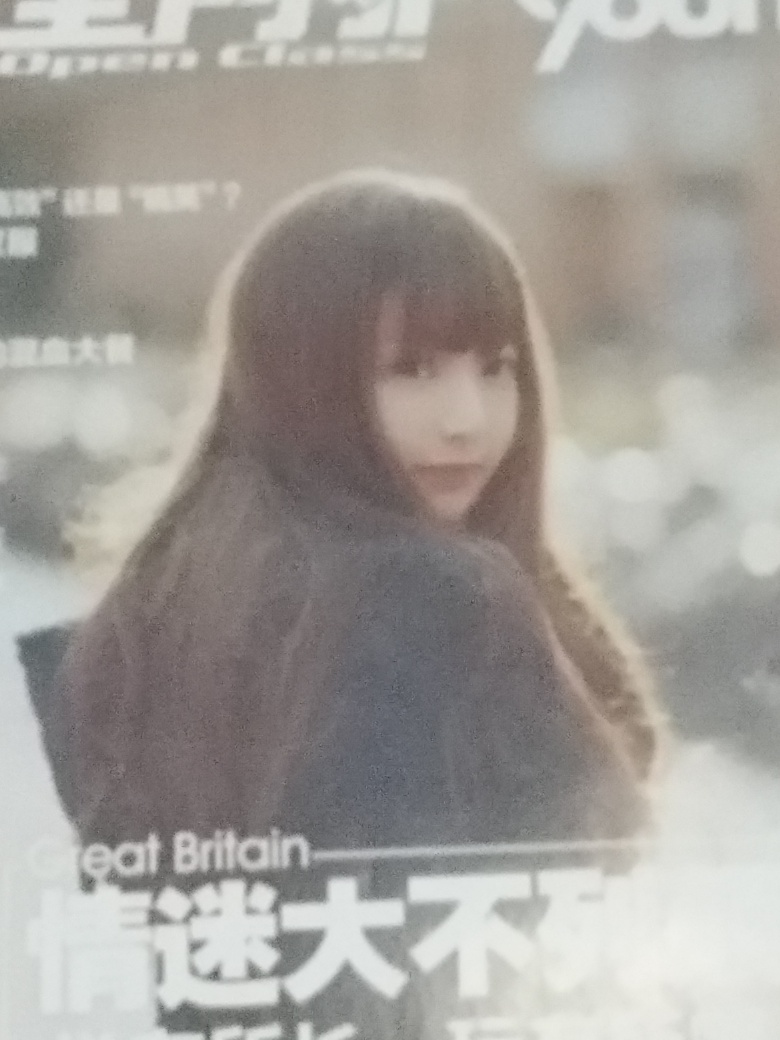What story do you think this image is trying to tell? The image seems to tell a story of reflection or introspection. The subject's gaze is directed away from the viewer, suggesting that she’s deep in thought or lost in a moment. The mood is contemplative, enhanced by the soft, blurred background, which allows the viewer to focus solely on the subject and her possible inner world. 